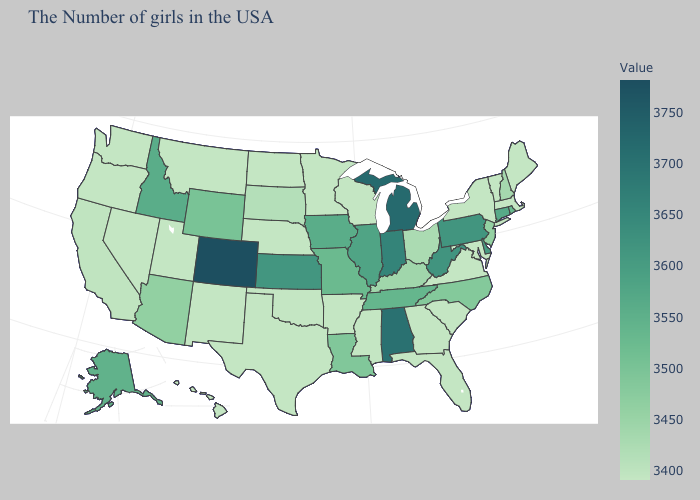Which states have the lowest value in the West?
Quick response, please. New Mexico, Utah, Montana, Nevada, Washington, Oregon, Hawaii. Does the map have missing data?
Short answer required. No. Does Colorado have the highest value in the USA?
Concise answer only. Yes. Does Texas have a higher value than Arizona?
Concise answer only. No. Which states have the lowest value in the USA?
Short answer required. Maine, Massachusetts, Vermont, New York, Maryland, Virginia, South Carolina, Florida, Georgia, Wisconsin, Mississippi, Arkansas, Minnesota, Nebraska, Oklahoma, Texas, North Dakota, New Mexico, Utah, Montana, Nevada, Washington, Oregon, Hawaii. 